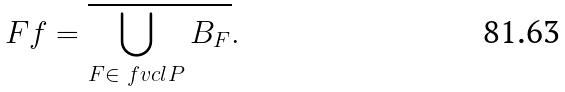<formula> <loc_0><loc_0><loc_500><loc_500>\ F f = \overline { \bigcup _ { F \in \ f v c l { P } } B _ { F } } .</formula> 